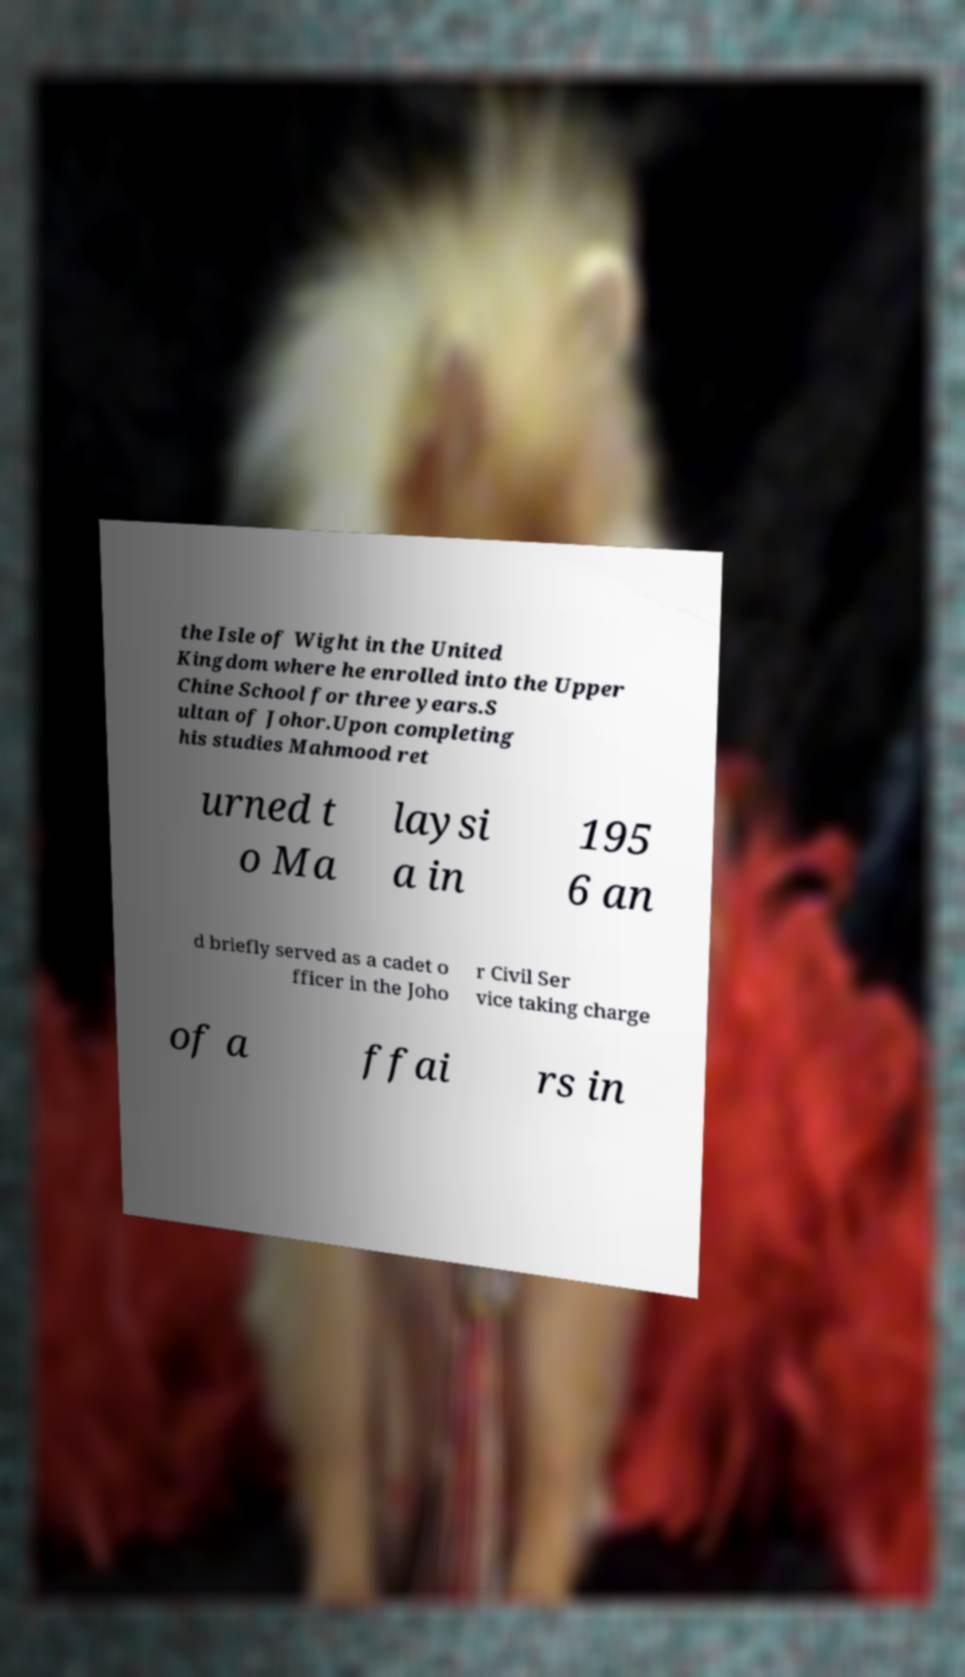Can you accurately transcribe the text from the provided image for me? the Isle of Wight in the United Kingdom where he enrolled into the Upper Chine School for three years.S ultan of Johor.Upon completing his studies Mahmood ret urned t o Ma laysi a in 195 6 an d briefly served as a cadet o fficer in the Joho r Civil Ser vice taking charge of a ffai rs in 